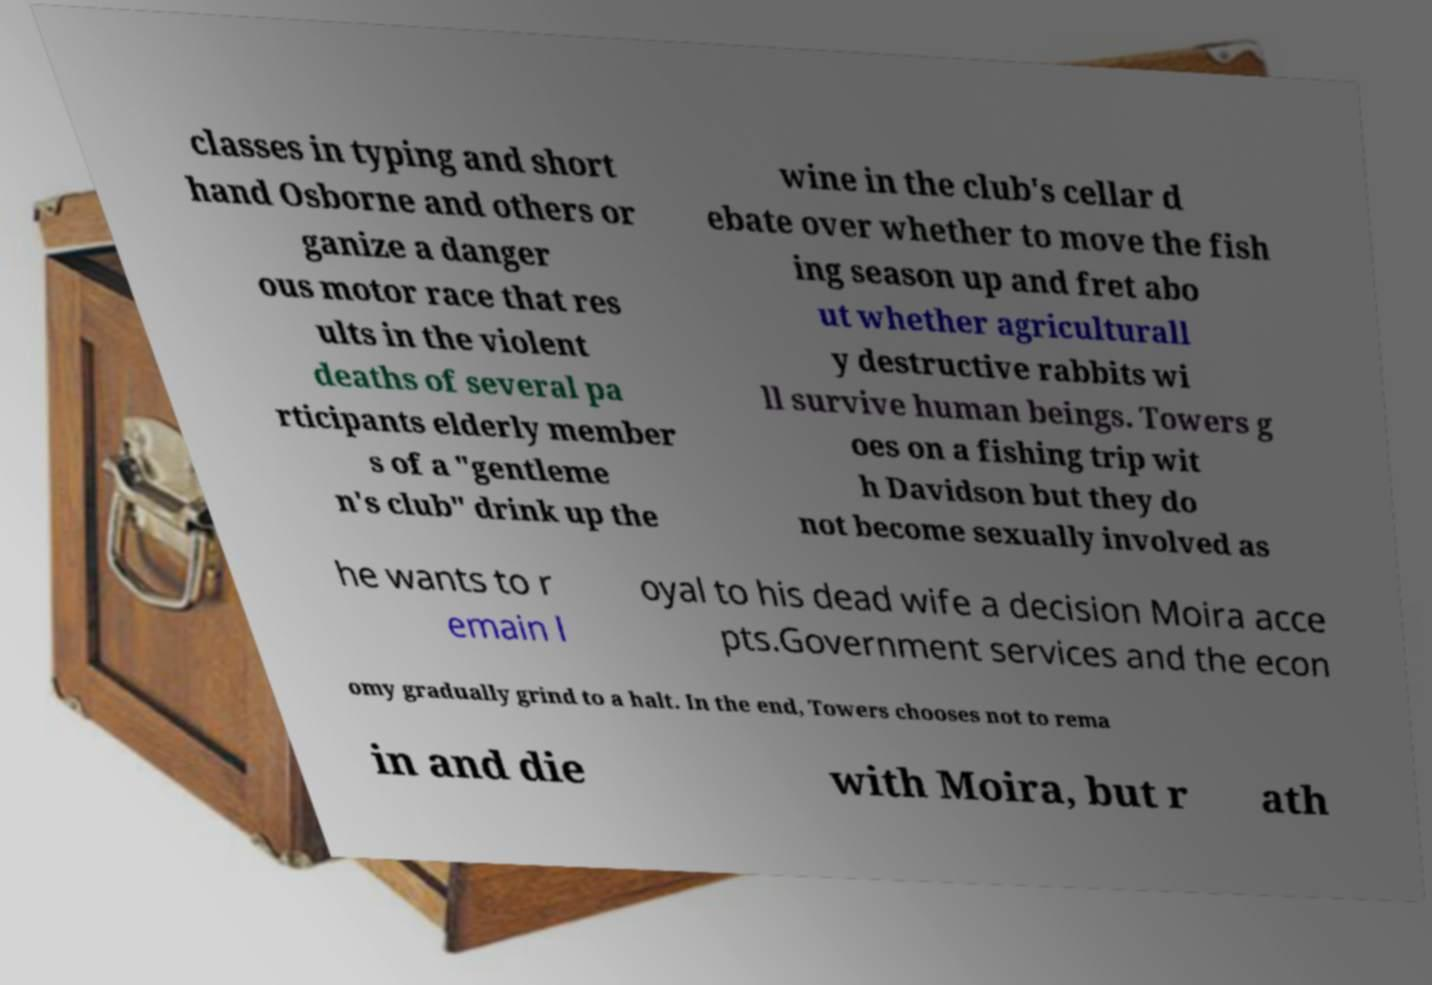Could you assist in decoding the text presented in this image and type it out clearly? classes in typing and short hand Osborne and others or ganize a danger ous motor race that res ults in the violent deaths of several pa rticipants elderly member s of a "gentleme n's club" drink up the wine in the club's cellar d ebate over whether to move the fish ing season up and fret abo ut whether agriculturall y destructive rabbits wi ll survive human beings. Towers g oes on a fishing trip wit h Davidson but they do not become sexually involved as he wants to r emain l oyal to his dead wife a decision Moira acce pts.Government services and the econ omy gradually grind to a halt. In the end, Towers chooses not to rema in and die with Moira, but r ath 